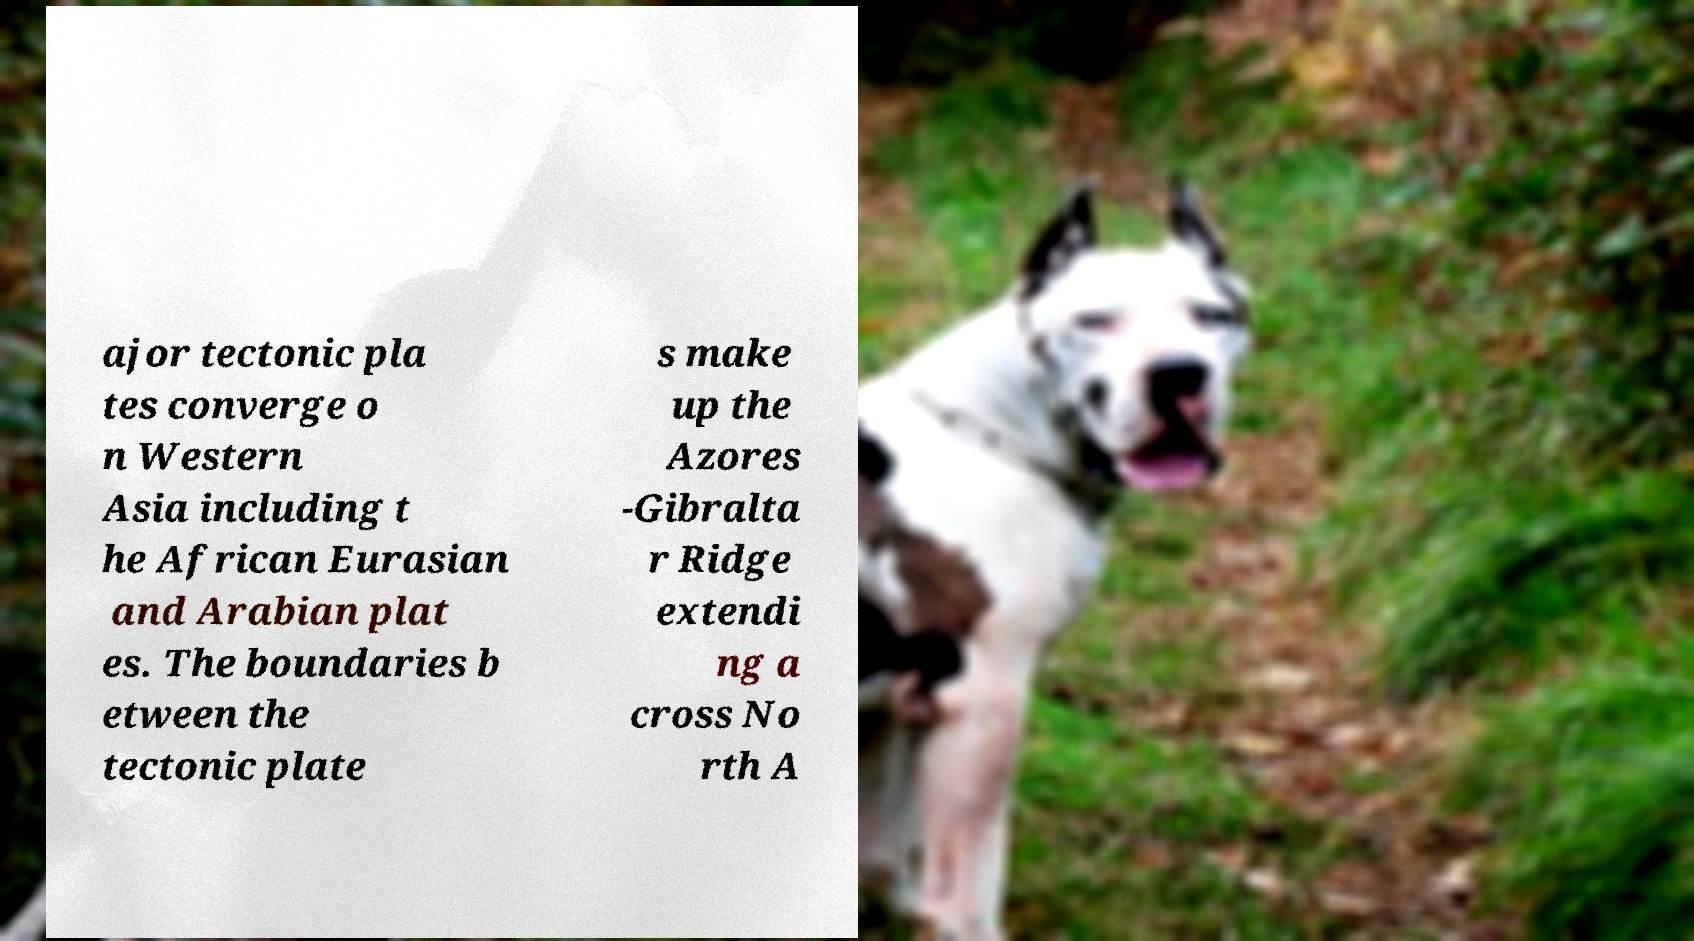For documentation purposes, I need the text within this image transcribed. Could you provide that? ajor tectonic pla tes converge o n Western Asia including t he African Eurasian and Arabian plat es. The boundaries b etween the tectonic plate s make up the Azores -Gibralta r Ridge extendi ng a cross No rth A 